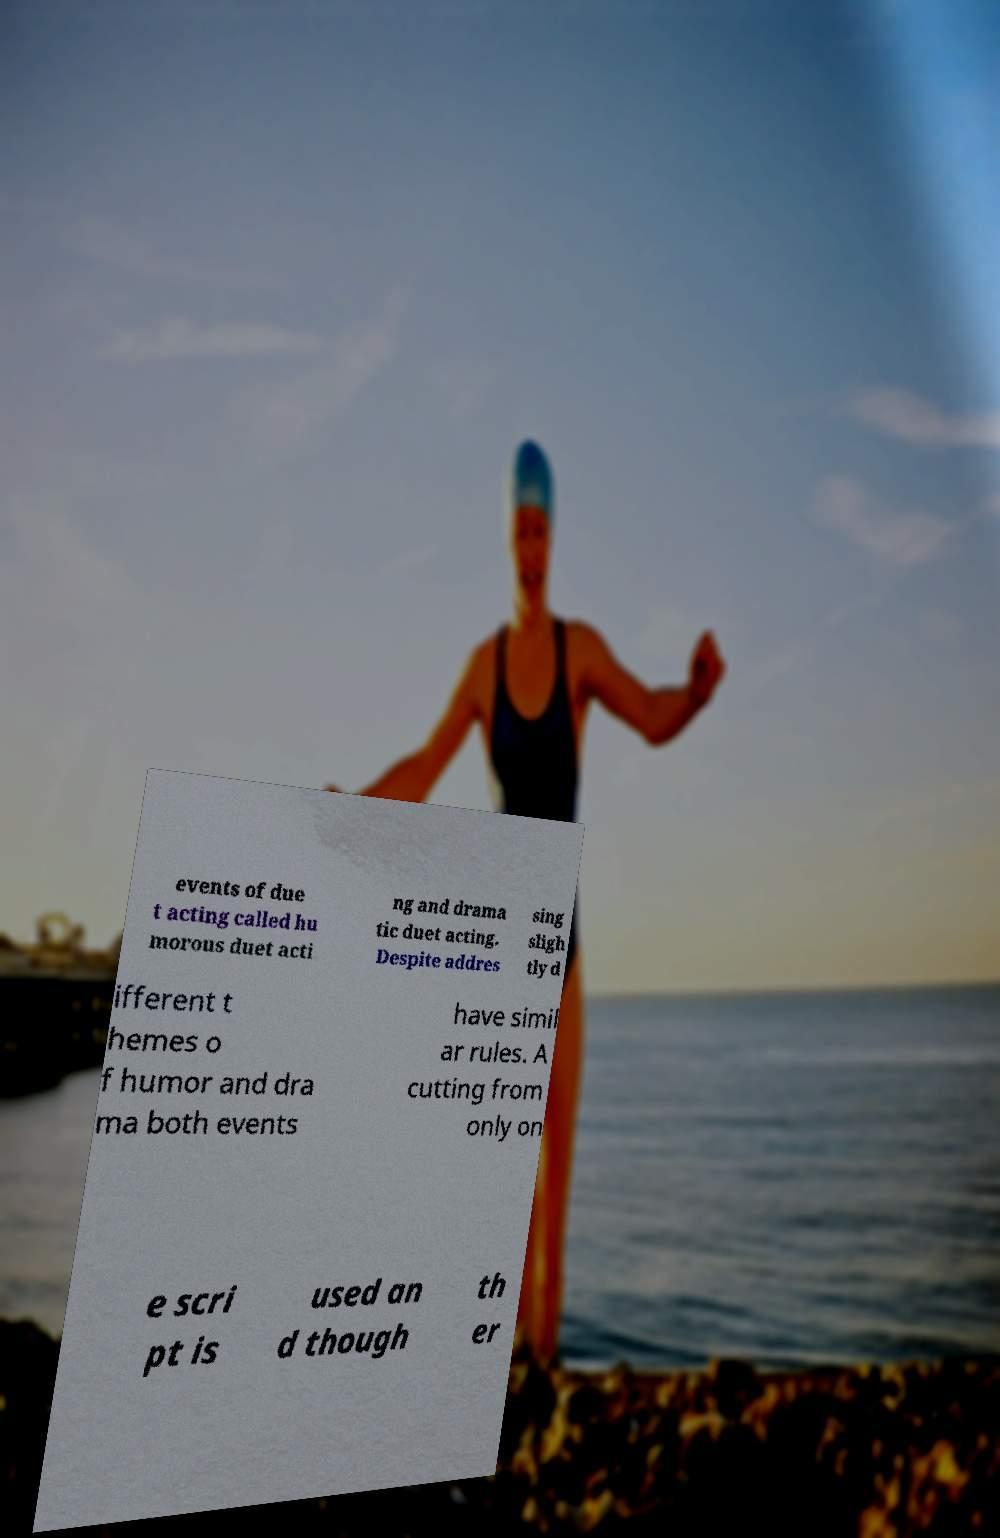Can you read and provide the text displayed in the image?This photo seems to have some interesting text. Can you extract and type it out for me? events of due t acting called hu morous duet acti ng and drama tic duet acting. Despite addres sing sligh tly d ifferent t hemes o f humor and dra ma both events have simil ar rules. A cutting from only on e scri pt is used an d though th er 